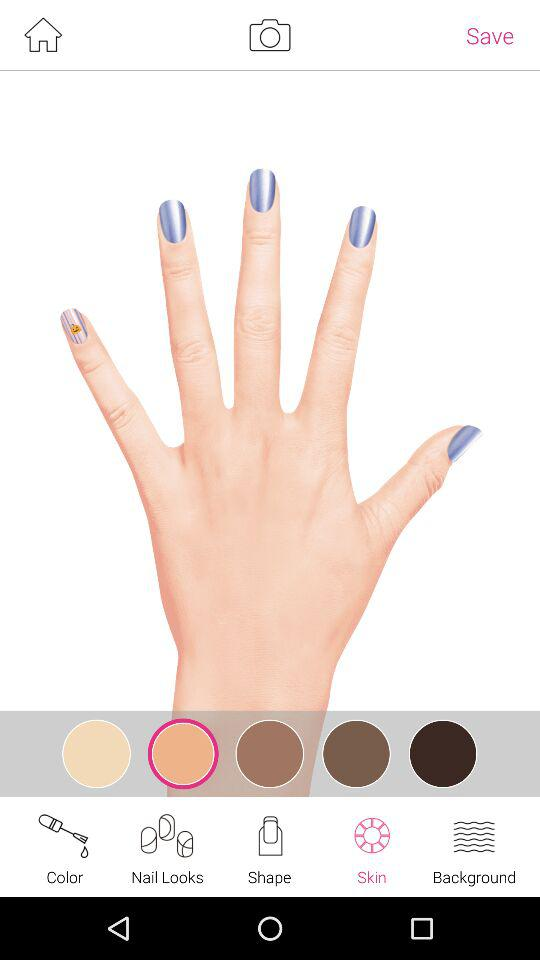Which option is selected in the taskbar? The selected option is "Skin". 